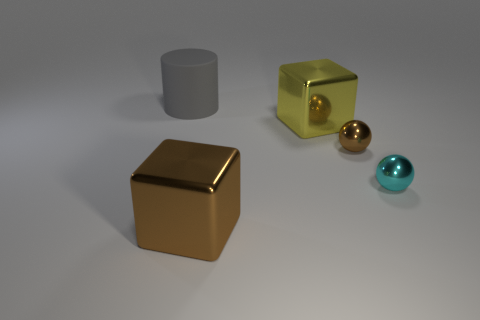Add 2 cyan things. How many objects exist? 7 Subtract all brown blocks. How many blocks are left? 1 Subtract all blocks. How many objects are left? 3 Subtract 1 cylinders. How many cylinders are left? 0 Subtract all green cylinders. How many blue spheres are left? 0 Add 3 small brown metallic balls. How many small brown metallic balls exist? 4 Subtract 0 purple balls. How many objects are left? 5 Subtract all purple blocks. Subtract all cyan spheres. How many blocks are left? 2 Subtract all large cylinders. Subtract all cyan things. How many objects are left? 3 Add 5 small cyan spheres. How many small cyan spheres are left? 6 